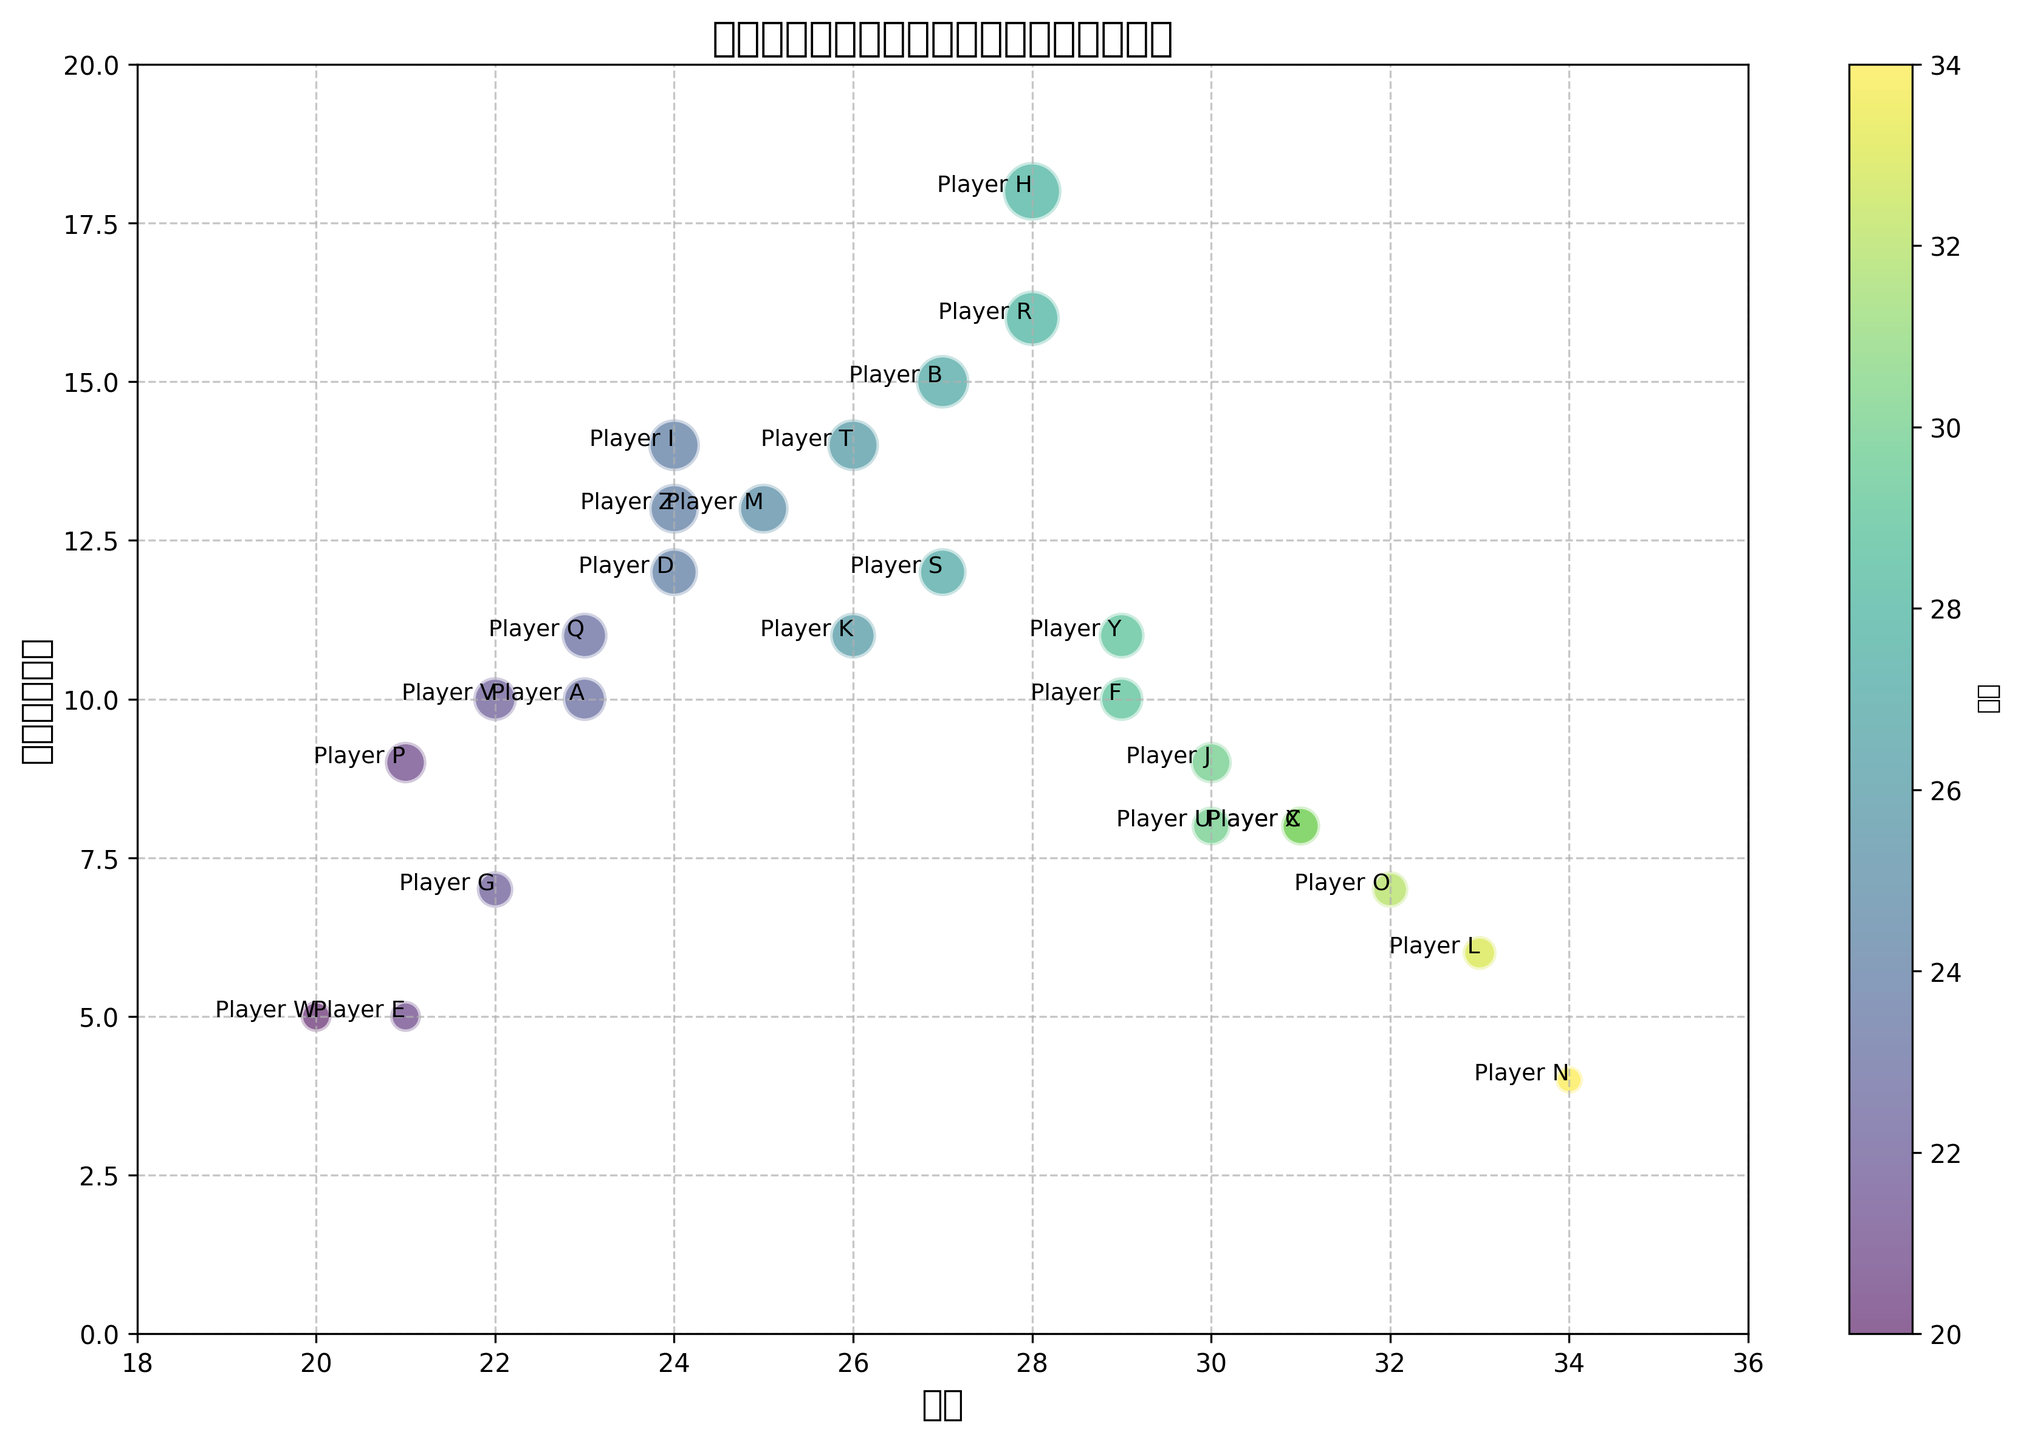哪些球员的赛季总进球数超过了15个？ 查看气泡图中的数据，可以看到Player B和Player H的赛季总进球数超过了15个。
Answer: Player B和Player H 谁是进球最多的球员，他的年龄是多少？ 从图表中，我们可以看到总进球数最高的是Player H，总进球数为18个。观察该球员的气泡颜色和位置，可以确定他的年龄是28岁。
Answer: Player H, 28岁 24岁年龄段的球员中，谁的进球数最多？ 根据气泡图中的标注和位置，24岁的球员中，进球数最多的是Player Z，总进球数为13个。
Answer: Player Z 年龄在30岁以上的球员中，谁的总进球数最多？ 通过观察气泡图中年龄大于30岁的几个球员，发现Player C和Player X等，但总进球数最多的是Player X，总进球数为8个。
Answer: Player X 气泡颜色最浅的球员是谁，他的总进球数是多少？ 颜色最浅的球员代表年龄最小的球员，从图表中能看出是Player W，他的总进球数为5个。
Answer: Player W, 5个 各年龄段总进球最多和最少的分别是多少？ 逐一分析每个年龄段气泡图的数据，总进球最多的年龄段是28岁（Player H, 18个进球），总进球最少的年龄段是34岁（Player N, 4个进球）。
Answer: 最多 18，最少 4 总进球为10个的球员中，谁的年龄最大？ 查看总进球为10个气泡的年龄，可以看到Player F和Player V，但年龄最大的为Player F，29岁。
Answer: Player F 哪个年龄段拥有最多的10+进球球员？ 分析图表中每个年龄段的球员数量，可以看到年龄段为28岁和24岁分别有3和3个总进球超过10个的球员，但数量最多的是24岁。
Answer: 24岁 球员中21岁年龄段的总进球数之和是多少？ 查看21岁年龄段的球员总进球数，可见Player E、Player P，两个球员的进球数分别为5和9，总和为14。
Answer: 14 总进球数10个的球员有几个？ 观察和统计气泡图中总进球数为10的球员，可以看到有Player A，Player F和Player V，总共三个。
Answer: 3个球员 